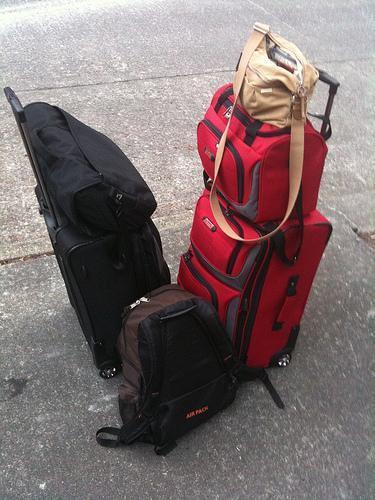How many bookbags do you see?
Give a very brief answer. 1. 